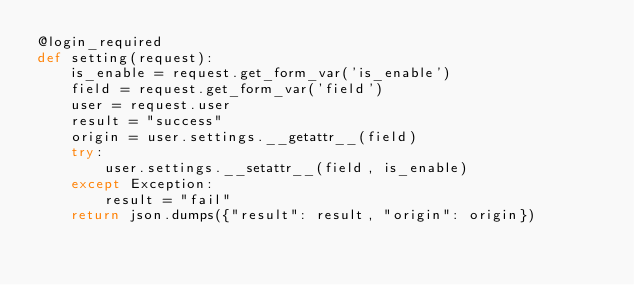Convert code to text. <code><loc_0><loc_0><loc_500><loc_500><_Python_>@login_required
def setting(request):
    is_enable = request.get_form_var('is_enable')
    field = request.get_form_var('field')
    user = request.user
    result = "success"
    origin = user.settings.__getattr__(field)
    try:
        user.settings.__setattr__(field, is_enable)
    except Exception:
        result = "fail"
    return json.dumps({"result": result, "origin": origin})
</code> 